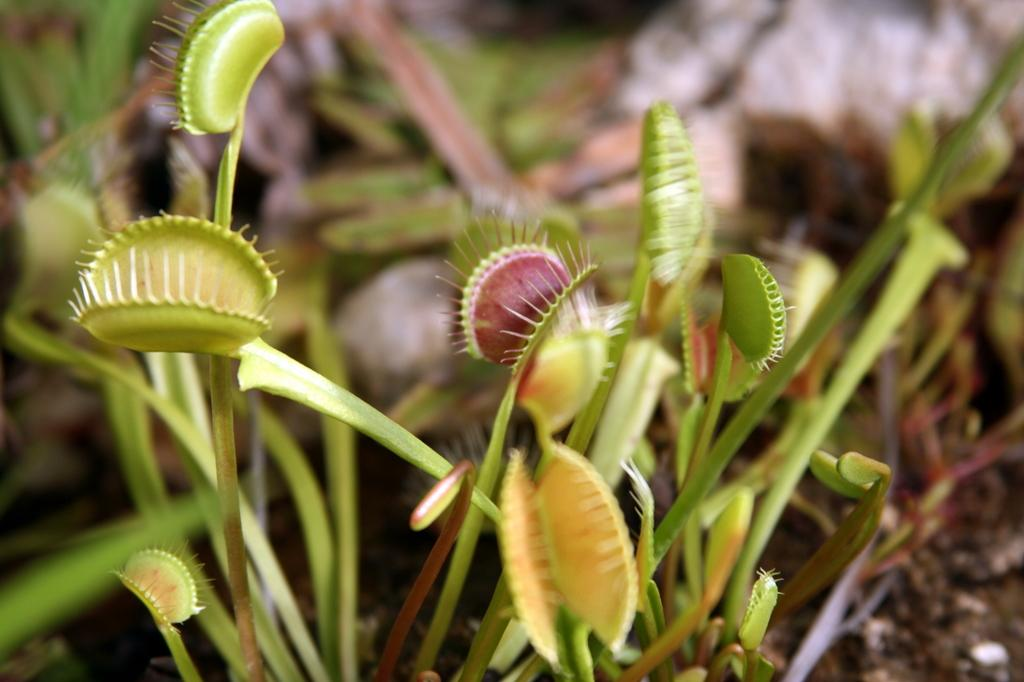What type of living organisms can be seen in the image? Plants can be seen in the image. What is the color of the plants in the image? The plants are green in color. What is the nationality of the tongue in the image? There is no tongue present in the image, so it is not possible to determine its nationality. 